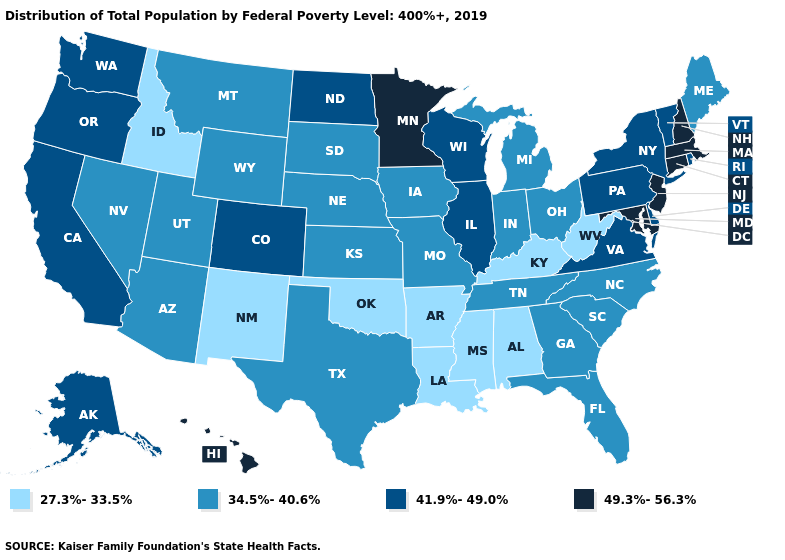Does Texas have the lowest value in the South?
Be succinct. No. Name the states that have a value in the range 27.3%-33.5%?
Give a very brief answer. Alabama, Arkansas, Idaho, Kentucky, Louisiana, Mississippi, New Mexico, Oklahoma, West Virginia. What is the value of Michigan?
Answer briefly. 34.5%-40.6%. Name the states that have a value in the range 27.3%-33.5%?
Be succinct. Alabama, Arkansas, Idaho, Kentucky, Louisiana, Mississippi, New Mexico, Oklahoma, West Virginia. What is the value of Alabama?
Short answer required. 27.3%-33.5%. Name the states that have a value in the range 27.3%-33.5%?
Short answer required. Alabama, Arkansas, Idaho, Kentucky, Louisiana, Mississippi, New Mexico, Oklahoma, West Virginia. How many symbols are there in the legend?
Concise answer only. 4. Name the states that have a value in the range 49.3%-56.3%?
Write a very short answer. Connecticut, Hawaii, Maryland, Massachusetts, Minnesota, New Hampshire, New Jersey. Does Minnesota have the highest value in the MidWest?
Give a very brief answer. Yes. Does the first symbol in the legend represent the smallest category?
Answer briefly. Yes. What is the value of North Dakota?
Write a very short answer. 41.9%-49.0%. What is the value of Mississippi?
Keep it brief. 27.3%-33.5%. Which states have the highest value in the USA?
Be succinct. Connecticut, Hawaii, Maryland, Massachusetts, Minnesota, New Hampshire, New Jersey. Which states have the highest value in the USA?
Answer briefly. Connecticut, Hawaii, Maryland, Massachusetts, Minnesota, New Hampshire, New Jersey. 